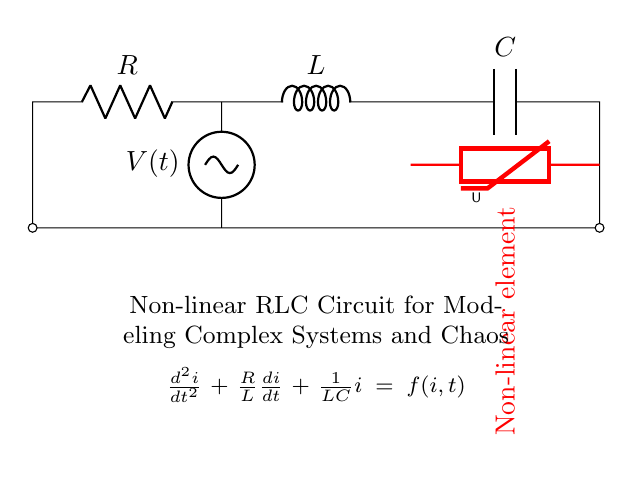What are the components of this circuit? The components consist of a resistor, an inductor, a capacitor, and a non-linear element (varistor). These components are arranged in a loop with the resistor connected to the inductor, followed by the capacitor, and ending with the non-linear element.
Answer: Resistor, Inductor, Capacitor, Non-linear element What is the function of the non-linear element in this circuit? The non-linear element (varistor) introduces a non-linear voltage-current relationship, which can lead to complex behaviors such as oscillations and chaos in the circuit. This element alters the circuit dynamics significantly compared to linear components alone.
Answer: Introduces non-linearity What is the equation representing this circuit? The differential equation for this circuit is \( \frac{d^2i}{dt^2} + \frac{R}{L}\frac{di}{dt} + \frac{1}{LC}i = f(i,t) \). This equation describes the relationship between the current \(i\) and time \(t\) in a non-linear RLC circuit, incorporating resistance, inductance, and capacitance.
Answer: \( \frac{d^2i}{dt^2} + \frac{R}{L}\frac{di}{dt} + \frac{1}{LC}i = f(i,t) \) Why is this circuit considered a non-linear RLC circuit? This circuit is classified as a non-linear RLC circuit due to the presence of the varistor as the non-linear element. Unlike a standard RLC circuit, where the relationship between voltage and current is linear, the non-linear behavior significantly influences the circuit's dynamic response, especially during chaotic conditions.
Answer: Non-linear behavior from varistor What is a potential application of this non-linear RLC circuit? A potential application of this non-linear RLC circuit involves studying chaos theory, which models complex and unpredictable behavior in systems, such as in signal processing, electrical engineering, or biological systems. The chaotic dynamics can help researchers understand and predict real-world phenomena.
Answer: Chaos theory studies 